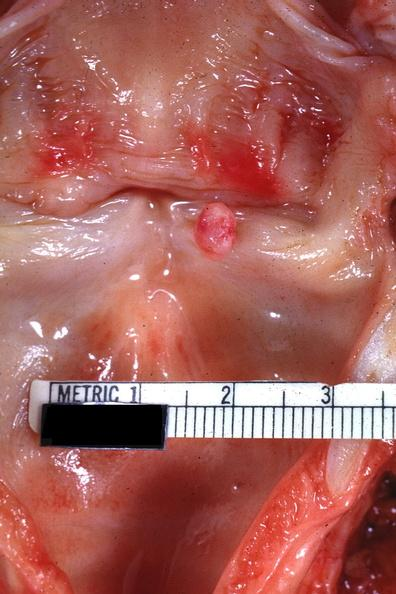s larynx present?
Answer the question using a single word or phrase. Yes 